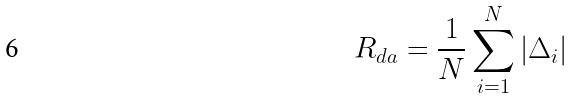<formula> <loc_0><loc_0><loc_500><loc_500>R _ { d a } = \frac { 1 } { N } \sum _ { i = 1 } ^ { N } | \Delta _ { i } |</formula> 